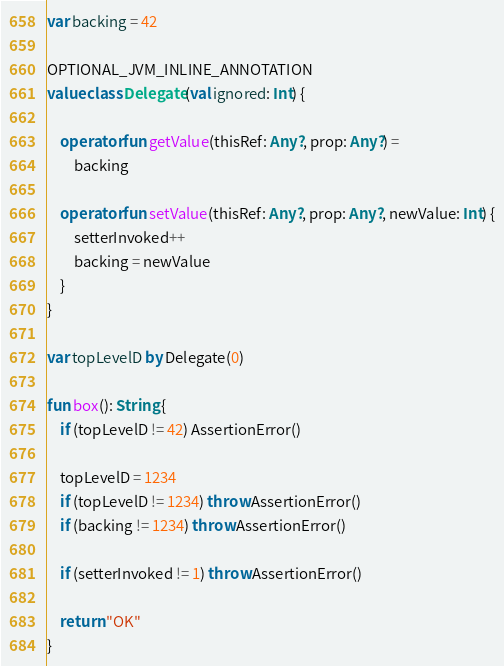Convert code to text. <code><loc_0><loc_0><loc_500><loc_500><_Kotlin_>var backing = 42

OPTIONAL_JVM_INLINE_ANNOTATION
value class Delegate(val ignored: Int) {

    operator fun getValue(thisRef: Any?, prop: Any?) =
        backing

    operator fun setValue(thisRef: Any?, prop: Any?, newValue: Int) {
        setterInvoked++
        backing = newValue
    }
}

var topLevelD by Delegate(0)

fun box(): String {
    if (topLevelD != 42) AssertionError()

    topLevelD = 1234
    if (topLevelD != 1234) throw AssertionError()
    if (backing != 1234) throw AssertionError()

    if (setterInvoked != 1) throw AssertionError()

    return "OK"
}</code> 